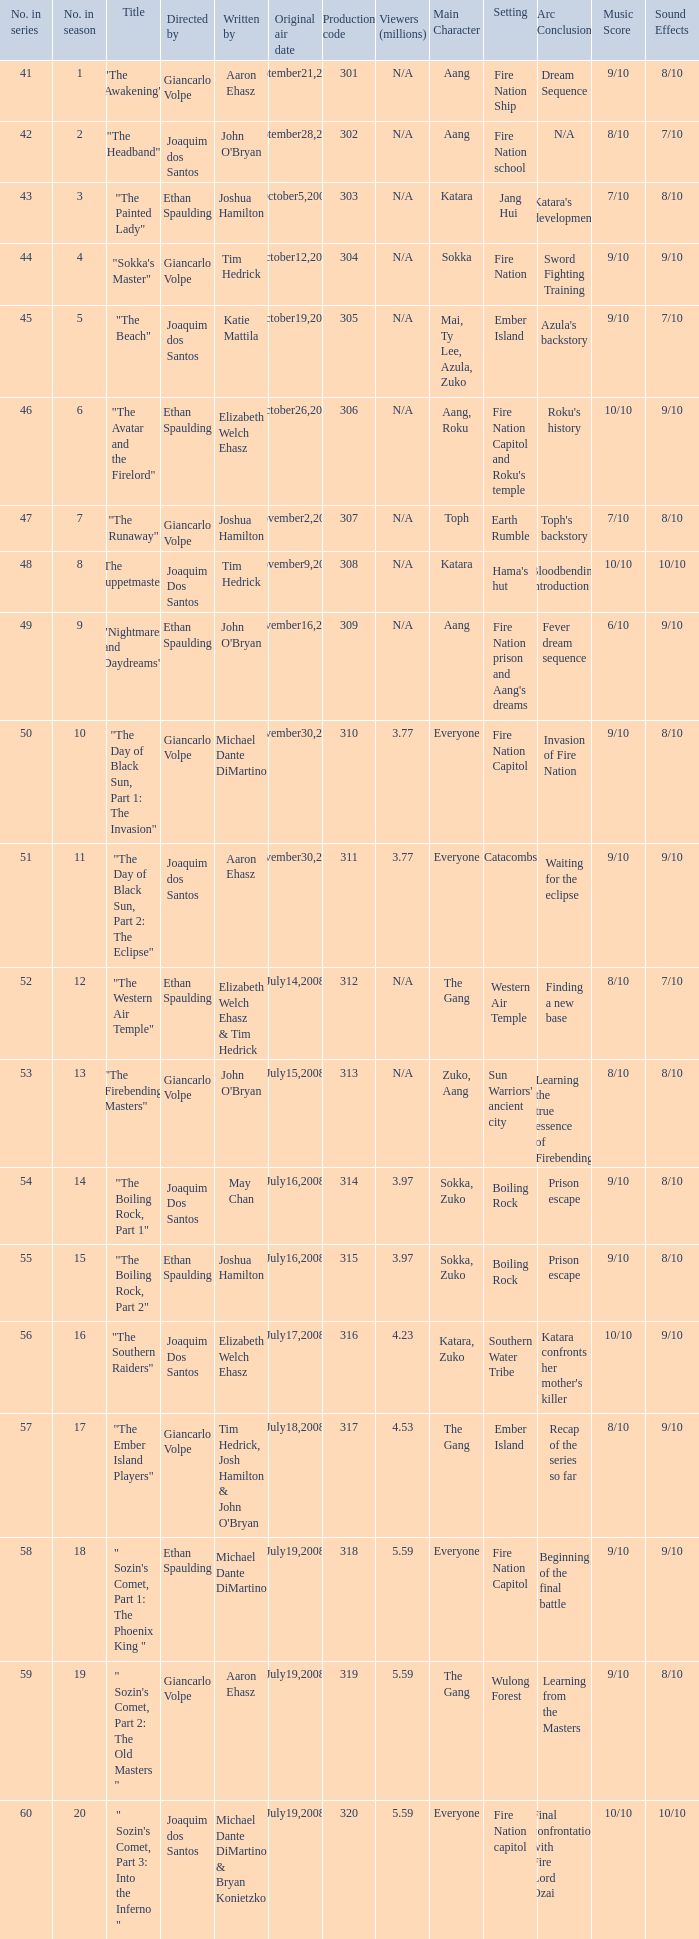What is the original air date for the episode with a production code of 318? July19,2008. 